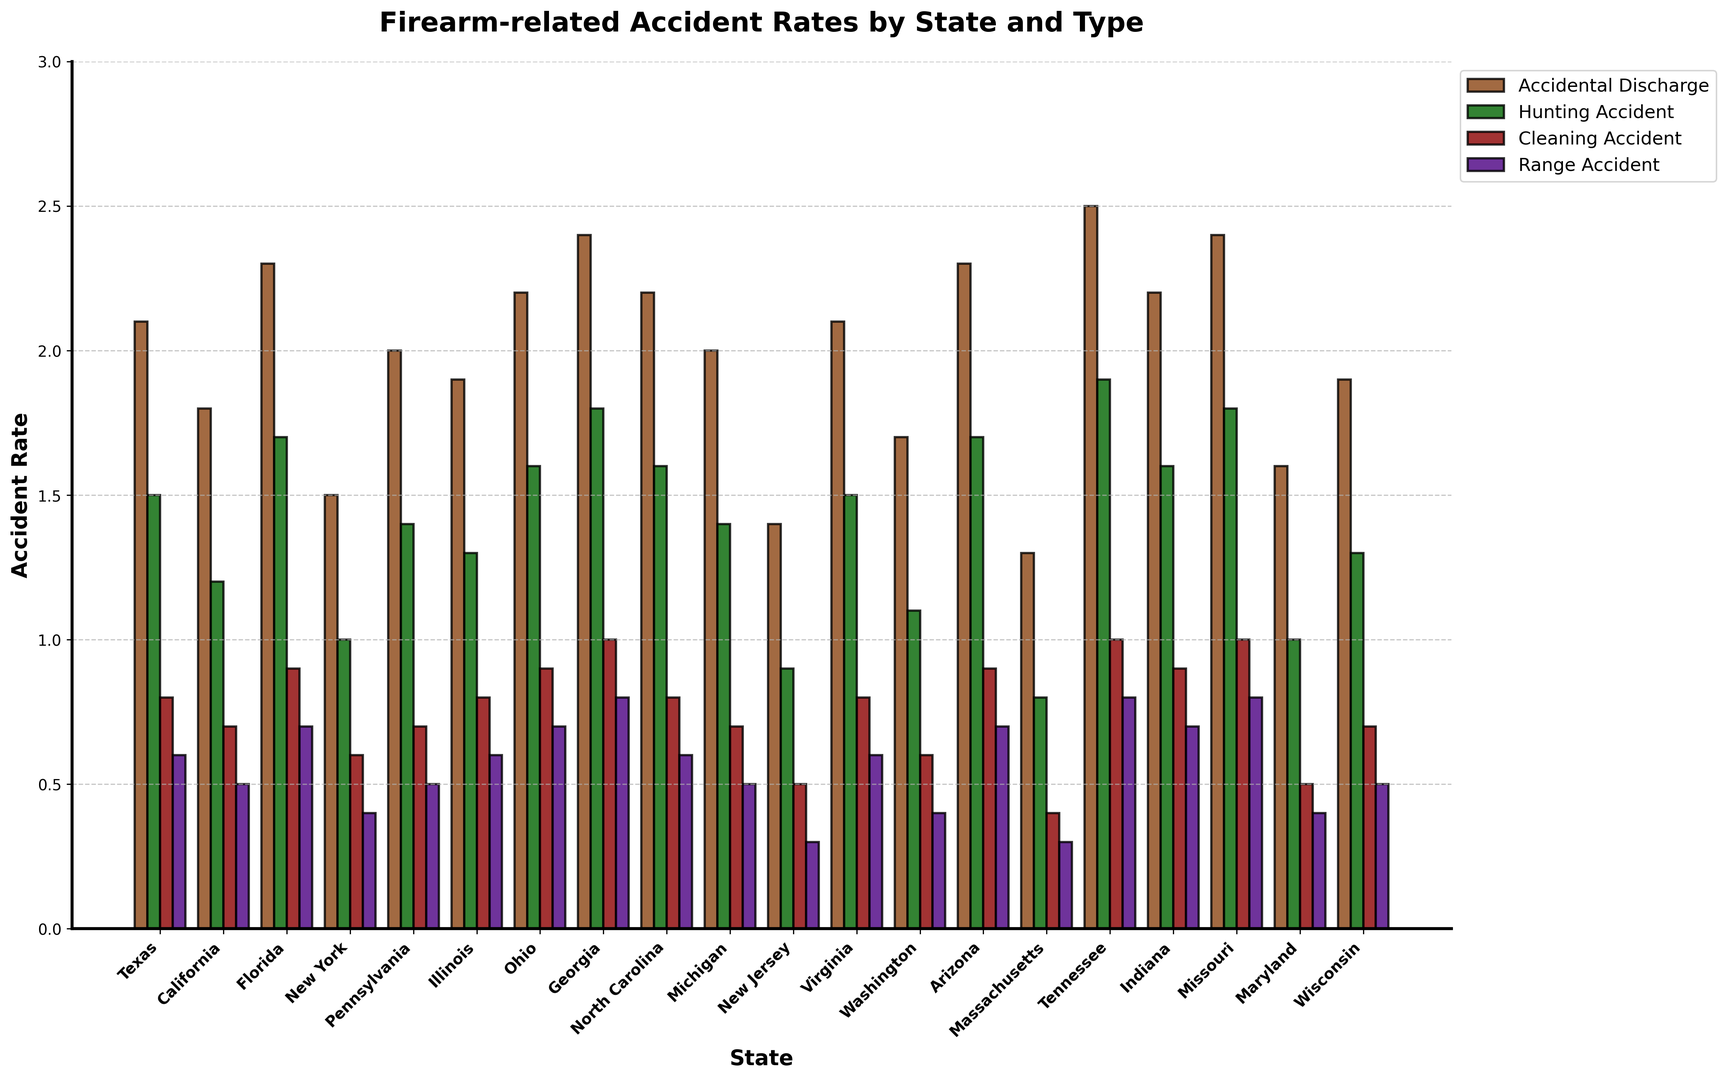What's the highest firearm accident rate for Texas, and which type of incident does it correspond to? In the plot, the tallest bar for Texas corresponds to the 'Accidental Discharge' category. This indicates that Texas has the highest firearm accident rate in this category.
Answer: Accidental Discharge, 2.1 Compare the rate of hunting accidents between Texas and California. The height of the bar for 'Hunting Accident' in Texas is higher than the one in California. Specifically, Texas has a rate of 1.5, while California has a rate of 1.2.
Answer: Texas is higher by 0.3 Which state shows the lowest rate for 'Cleaning Accident', and what is the rate? The shortest bar in the 'Cleaning Accident' category is observed for Massachusetts. This means that Massachusetts has the lowest rate for cleaning accidents.
Answer: Massachusetts, 0.4 What is the average rate of 'Range Accident' across all states? To find the average, sum up the rates for 'Range Accident' across all states and divide by the number of states. The values are [0.6, 0.5, 0.7, 0.4, 0.5, 0.6, 0.7, 0.8, 0.6, 0.5, 0.3, 0.6, 0.4, 0.7, 0.3, 0.8, 0.7, 0.8, 0.4, 0.5], which gives a sum of 11.1. Dividing this sum by 20 states, the average rate is 0.555.
Answer: 0.555 Between Ohio and Georgia, which state has a higher average rate across all accident types? Calculate the average rate for each state by summing the rates across all incident types and dividing by 4. For Ohio: (2.2+1.6+0.9+0.7)/4 = 1.35. For Georgia: (2.4+1.8+1.0+0.8)/4 = 1.5. Georgia has a higher average.
Answer: Georgia, 1.5 How many states have 'Accidental Discharge' rates greater than 2.0? Identify the bars in the 'Accidental Discharge' category that are greater than 2.0. The states are Texas, Florida, Ohio, Georgia, Tennessee, Missouri.
Answer: 6 Which type of incident has the highest overall rate among all states combined, and what is that rate? Sum the accident rates for each incident type across all states and compare. Summing across states gives: Accidental Discharge = 38.6, Hunting Accident = 27.3, Cleaning Accident = 14.0, Range Accident = 11.1. 'Accidental Discharge' has the highest overall rate.
Answer: Accidental Discharge, 38.6 Compare the 'Hunting Accident' rates between New York and Pennsylvania. Which state has a higher rate and by how much? Check the heights of the bars for 'Hunting Accident'. New York has a rate of 1.0, and Pennsylvania has a rate of 1.4. Pennsylvania's rate is higher by 0.4.
Answer: Pennsylvania, 0.4 What is the total accident rate for Virginia across all types of incidents? Sum up the rates for Virginia: (2.1 + 1.5 + 0.8 + 0.6) = 5.0
Answer: 5.0 